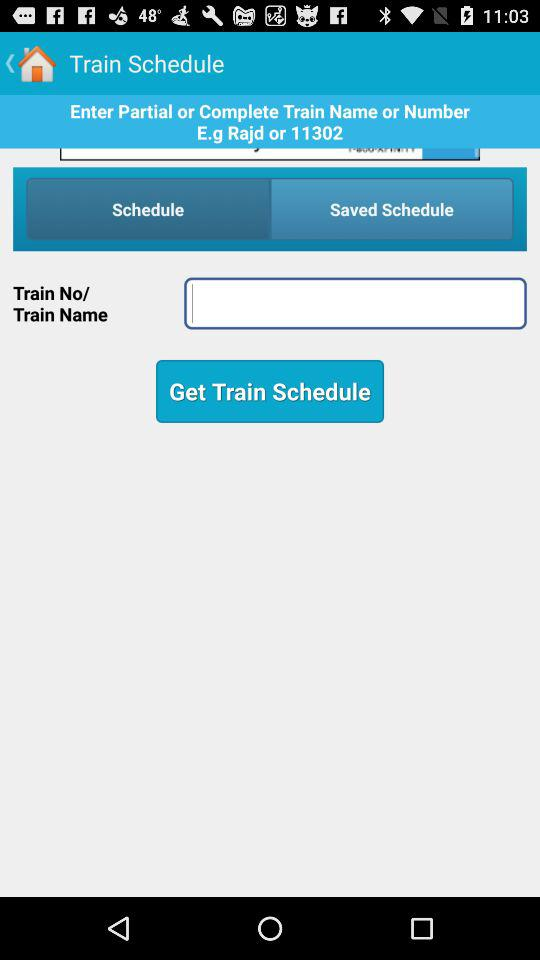Which tab is selected? The selected tab is "Schedule". 